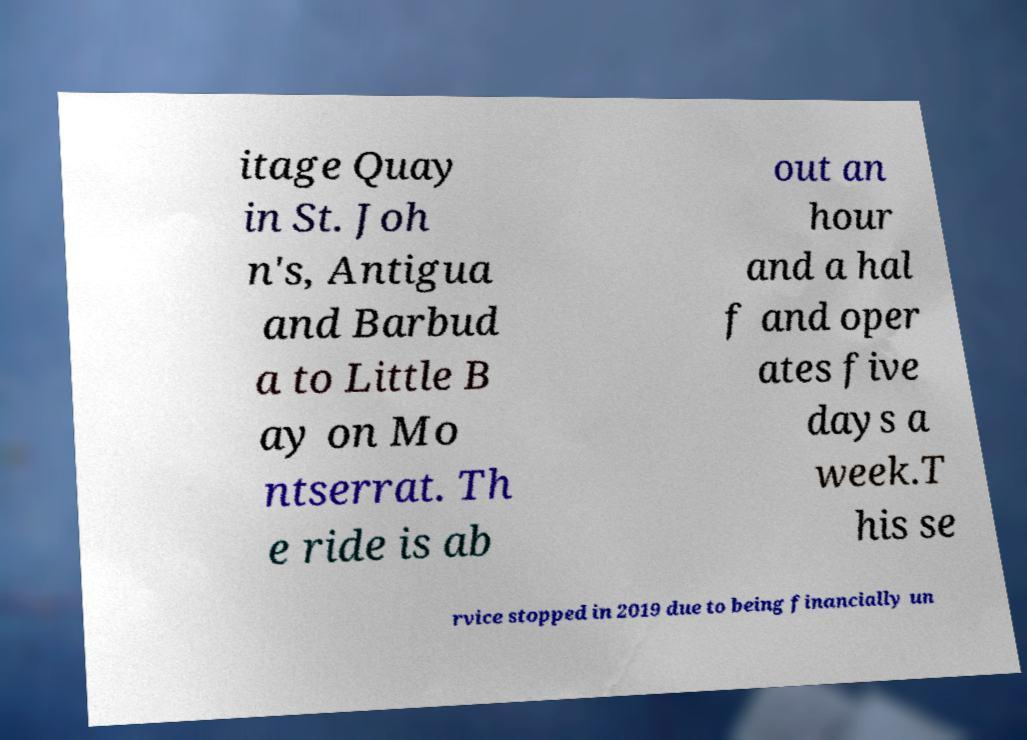What messages or text are displayed in this image? I need them in a readable, typed format. itage Quay in St. Joh n's, Antigua and Barbud a to Little B ay on Mo ntserrat. Th e ride is ab out an hour and a hal f and oper ates five days a week.T his se rvice stopped in 2019 due to being financially un 